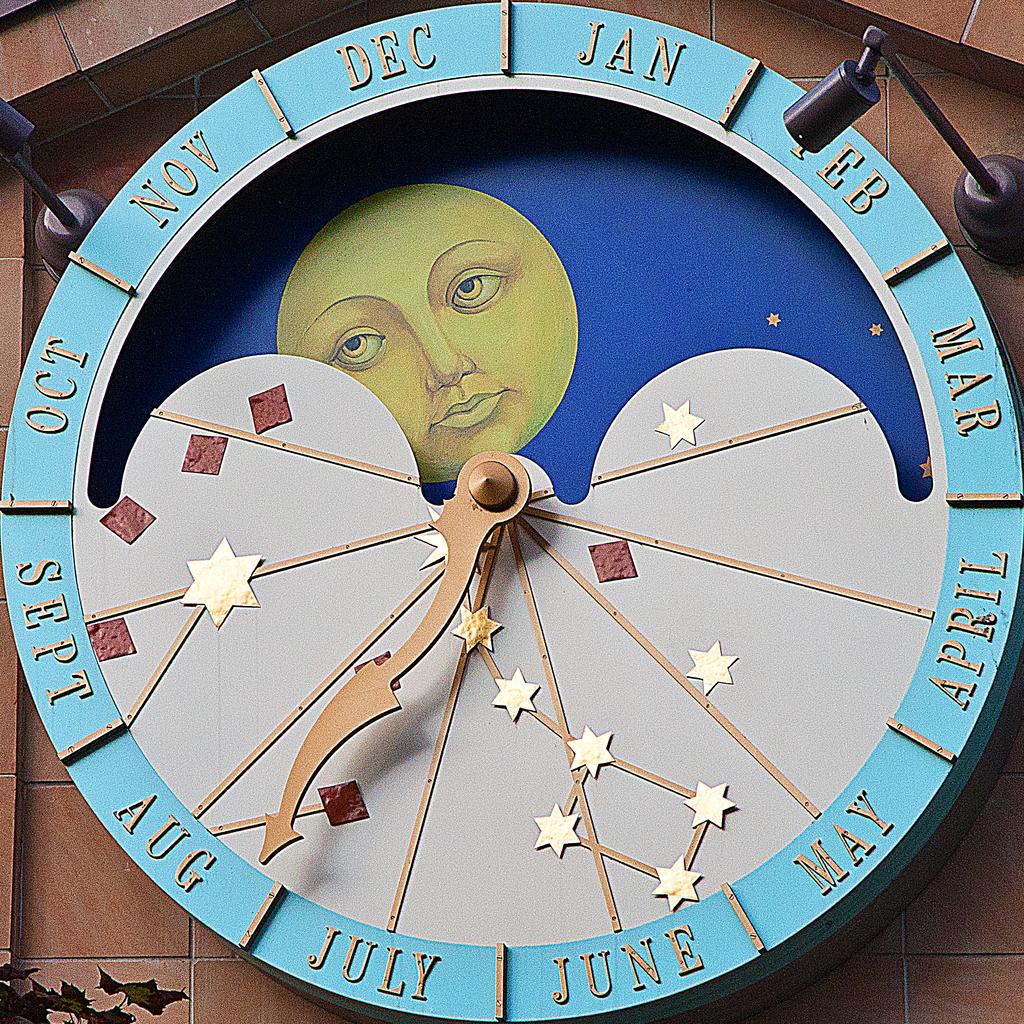What month does the clock point to?
Ensure brevity in your answer.  August. What month is under the light?
Provide a short and direct response. Feb. 